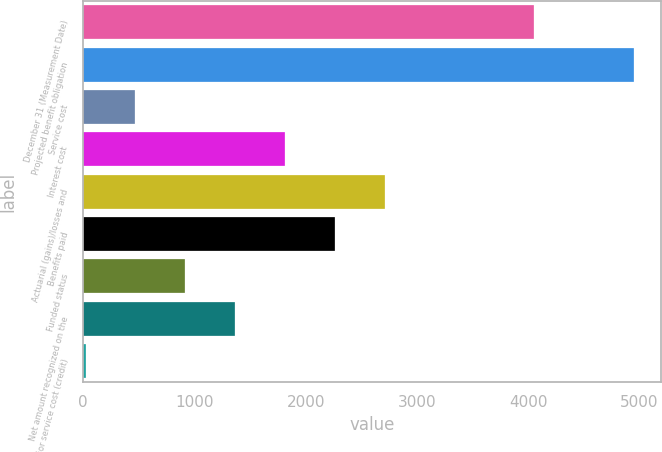Convert chart to OTSL. <chart><loc_0><loc_0><loc_500><loc_500><bar_chart><fcel>December 31 (Measurement Date)<fcel>Projected benefit obligation<fcel>Service cost<fcel>Interest cost<fcel>Actuarial (gains)/losses and<fcel>Benefits paid<fcel>Funded status<fcel>Net amount recognized on the<fcel>Prior service cost (credit)<nl><fcel>4051.3<fcel>4946.7<fcel>469.7<fcel>1812.8<fcel>2708.2<fcel>2260.5<fcel>917.4<fcel>1365.1<fcel>22<nl></chart> 